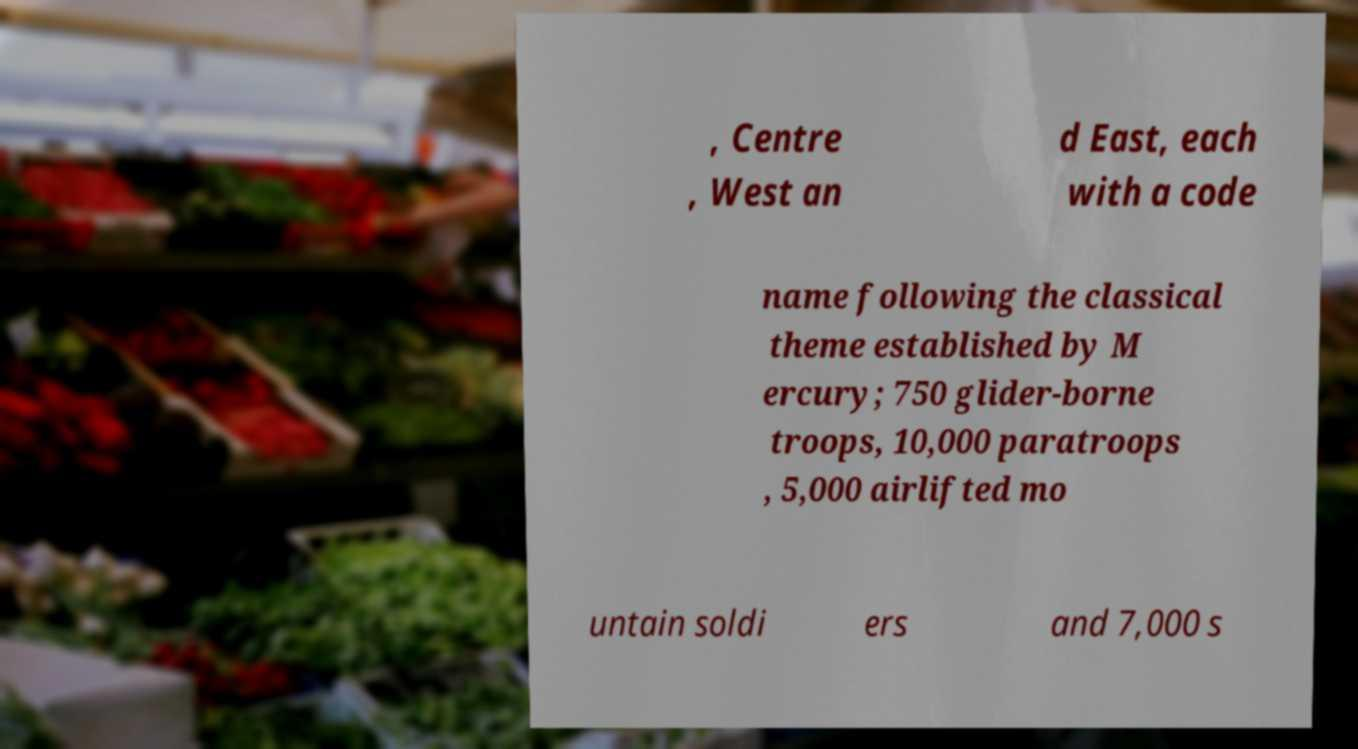For documentation purposes, I need the text within this image transcribed. Could you provide that? , Centre , West an d East, each with a code name following the classical theme established by M ercury; 750 glider-borne troops, 10,000 paratroops , 5,000 airlifted mo untain soldi ers and 7,000 s 